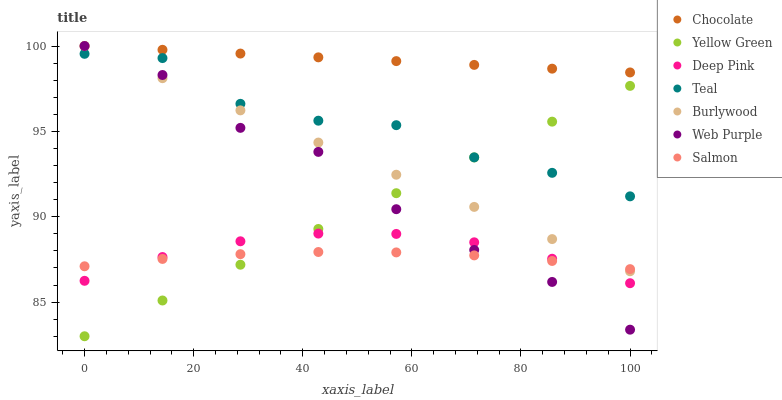Does Salmon have the minimum area under the curve?
Answer yes or no. Yes. Does Chocolate have the maximum area under the curve?
Answer yes or no. Yes. Does Yellow Green have the minimum area under the curve?
Answer yes or no. No. Does Yellow Green have the maximum area under the curve?
Answer yes or no. No. Is Chocolate the smoothest?
Answer yes or no. Yes. Is Teal the roughest?
Answer yes or no. Yes. Is Yellow Green the smoothest?
Answer yes or no. No. Is Yellow Green the roughest?
Answer yes or no. No. Does Yellow Green have the lowest value?
Answer yes or no. Yes. Does Burlywood have the lowest value?
Answer yes or no. No. Does Web Purple have the highest value?
Answer yes or no. Yes. Does Yellow Green have the highest value?
Answer yes or no. No. Is Teal less than Chocolate?
Answer yes or no. Yes. Is Teal greater than Deep Pink?
Answer yes or no. Yes. Does Yellow Green intersect Salmon?
Answer yes or no. Yes. Is Yellow Green less than Salmon?
Answer yes or no. No. Is Yellow Green greater than Salmon?
Answer yes or no. No. Does Teal intersect Chocolate?
Answer yes or no. No. 